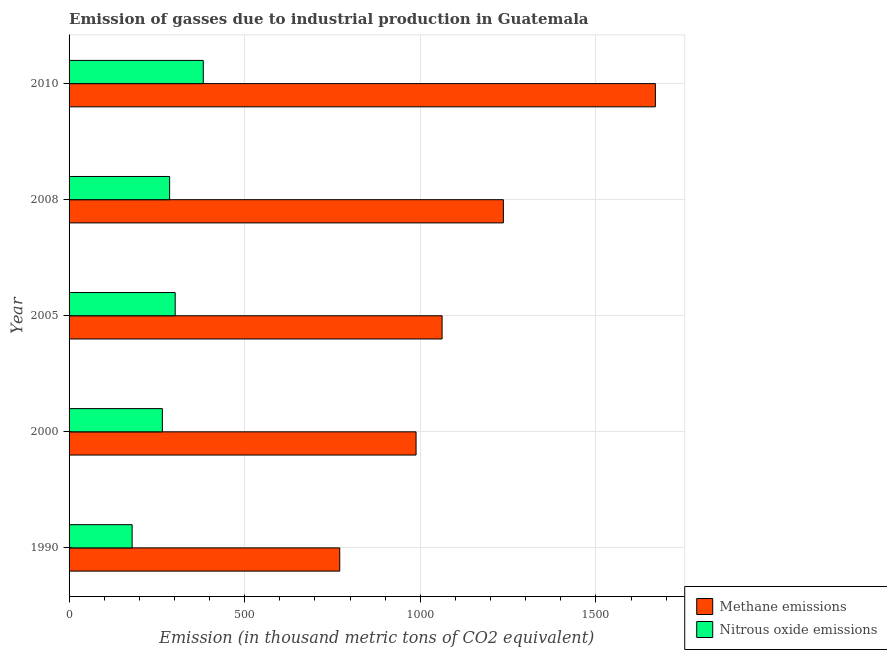How many different coloured bars are there?
Offer a terse response. 2. How many bars are there on the 5th tick from the bottom?
Make the answer very short. 2. In how many cases, is the number of bars for a given year not equal to the number of legend labels?
Your answer should be compact. 0. What is the amount of methane emissions in 2008?
Give a very brief answer. 1236.5. Across all years, what is the maximum amount of nitrous oxide emissions?
Provide a succinct answer. 382.1. Across all years, what is the minimum amount of nitrous oxide emissions?
Offer a very short reply. 179.5. In which year was the amount of nitrous oxide emissions maximum?
Provide a succinct answer. 2010. In which year was the amount of methane emissions minimum?
Your answer should be very brief. 1990. What is the total amount of methane emissions in the graph?
Provide a succinct answer. 5726.3. What is the difference between the amount of methane emissions in 1990 and that in 2005?
Your response must be concise. -291.4. What is the difference between the amount of methane emissions in 2010 and the amount of nitrous oxide emissions in 1990?
Offer a very short reply. 1489.8. What is the average amount of nitrous oxide emissions per year?
Make the answer very short. 283.12. In the year 2010, what is the difference between the amount of nitrous oxide emissions and amount of methane emissions?
Provide a short and direct response. -1287.2. In how many years, is the amount of nitrous oxide emissions greater than 900 thousand metric tons?
Provide a succinct answer. 0. What is the ratio of the amount of nitrous oxide emissions in 1990 to that in 2005?
Make the answer very short. 0.59. Is the difference between the amount of methane emissions in 2008 and 2010 greater than the difference between the amount of nitrous oxide emissions in 2008 and 2010?
Ensure brevity in your answer.  No. What is the difference between the highest and the second highest amount of nitrous oxide emissions?
Offer a very short reply. 80. What is the difference between the highest and the lowest amount of methane emissions?
Provide a short and direct response. 898.7. Is the sum of the amount of methane emissions in 2000 and 2008 greater than the maximum amount of nitrous oxide emissions across all years?
Offer a terse response. Yes. What does the 1st bar from the top in 1990 represents?
Offer a terse response. Nitrous oxide emissions. What does the 1st bar from the bottom in 2008 represents?
Your answer should be compact. Methane emissions. Are all the bars in the graph horizontal?
Offer a terse response. Yes. What is the difference between two consecutive major ticks on the X-axis?
Make the answer very short. 500. Does the graph contain grids?
Offer a terse response. Yes. Where does the legend appear in the graph?
Your answer should be compact. Bottom right. How many legend labels are there?
Keep it short and to the point. 2. What is the title of the graph?
Your response must be concise. Emission of gasses due to industrial production in Guatemala. Does "Technicians" appear as one of the legend labels in the graph?
Provide a succinct answer. No. What is the label or title of the X-axis?
Give a very brief answer. Emission (in thousand metric tons of CO2 equivalent). What is the label or title of the Y-axis?
Provide a succinct answer. Year. What is the Emission (in thousand metric tons of CO2 equivalent) in Methane emissions in 1990?
Keep it short and to the point. 770.6. What is the Emission (in thousand metric tons of CO2 equivalent) in Nitrous oxide emissions in 1990?
Your answer should be compact. 179.5. What is the Emission (in thousand metric tons of CO2 equivalent) in Methane emissions in 2000?
Your response must be concise. 987.9. What is the Emission (in thousand metric tons of CO2 equivalent) of Nitrous oxide emissions in 2000?
Your answer should be very brief. 265.6. What is the Emission (in thousand metric tons of CO2 equivalent) of Methane emissions in 2005?
Provide a succinct answer. 1062. What is the Emission (in thousand metric tons of CO2 equivalent) in Nitrous oxide emissions in 2005?
Make the answer very short. 302.1. What is the Emission (in thousand metric tons of CO2 equivalent) of Methane emissions in 2008?
Your answer should be compact. 1236.5. What is the Emission (in thousand metric tons of CO2 equivalent) of Nitrous oxide emissions in 2008?
Offer a very short reply. 286.3. What is the Emission (in thousand metric tons of CO2 equivalent) of Methane emissions in 2010?
Offer a very short reply. 1669.3. What is the Emission (in thousand metric tons of CO2 equivalent) of Nitrous oxide emissions in 2010?
Give a very brief answer. 382.1. Across all years, what is the maximum Emission (in thousand metric tons of CO2 equivalent) in Methane emissions?
Your response must be concise. 1669.3. Across all years, what is the maximum Emission (in thousand metric tons of CO2 equivalent) in Nitrous oxide emissions?
Your answer should be very brief. 382.1. Across all years, what is the minimum Emission (in thousand metric tons of CO2 equivalent) of Methane emissions?
Offer a terse response. 770.6. Across all years, what is the minimum Emission (in thousand metric tons of CO2 equivalent) in Nitrous oxide emissions?
Offer a very short reply. 179.5. What is the total Emission (in thousand metric tons of CO2 equivalent) of Methane emissions in the graph?
Give a very brief answer. 5726.3. What is the total Emission (in thousand metric tons of CO2 equivalent) in Nitrous oxide emissions in the graph?
Give a very brief answer. 1415.6. What is the difference between the Emission (in thousand metric tons of CO2 equivalent) of Methane emissions in 1990 and that in 2000?
Your answer should be compact. -217.3. What is the difference between the Emission (in thousand metric tons of CO2 equivalent) in Nitrous oxide emissions in 1990 and that in 2000?
Offer a very short reply. -86.1. What is the difference between the Emission (in thousand metric tons of CO2 equivalent) of Methane emissions in 1990 and that in 2005?
Your answer should be compact. -291.4. What is the difference between the Emission (in thousand metric tons of CO2 equivalent) in Nitrous oxide emissions in 1990 and that in 2005?
Provide a succinct answer. -122.6. What is the difference between the Emission (in thousand metric tons of CO2 equivalent) of Methane emissions in 1990 and that in 2008?
Provide a short and direct response. -465.9. What is the difference between the Emission (in thousand metric tons of CO2 equivalent) in Nitrous oxide emissions in 1990 and that in 2008?
Your answer should be very brief. -106.8. What is the difference between the Emission (in thousand metric tons of CO2 equivalent) of Methane emissions in 1990 and that in 2010?
Your answer should be compact. -898.7. What is the difference between the Emission (in thousand metric tons of CO2 equivalent) of Nitrous oxide emissions in 1990 and that in 2010?
Keep it short and to the point. -202.6. What is the difference between the Emission (in thousand metric tons of CO2 equivalent) in Methane emissions in 2000 and that in 2005?
Ensure brevity in your answer.  -74.1. What is the difference between the Emission (in thousand metric tons of CO2 equivalent) of Nitrous oxide emissions in 2000 and that in 2005?
Offer a very short reply. -36.5. What is the difference between the Emission (in thousand metric tons of CO2 equivalent) of Methane emissions in 2000 and that in 2008?
Offer a terse response. -248.6. What is the difference between the Emission (in thousand metric tons of CO2 equivalent) of Nitrous oxide emissions in 2000 and that in 2008?
Your response must be concise. -20.7. What is the difference between the Emission (in thousand metric tons of CO2 equivalent) in Methane emissions in 2000 and that in 2010?
Keep it short and to the point. -681.4. What is the difference between the Emission (in thousand metric tons of CO2 equivalent) in Nitrous oxide emissions in 2000 and that in 2010?
Offer a very short reply. -116.5. What is the difference between the Emission (in thousand metric tons of CO2 equivalent) of Methane emissions in 2005 and that in 2008?
Offer a very short reply. -174.5. What is the difference between the Emission (in thousand metric tons of CO2 equivalent) of Methane emissions in 2005 and that in 2010?
Offer a very short reply. -607.3. What is the difference between the Emission (in thousand metric tons of CO2 equivalent) in Nitrous oxide emissions in 2005 and that in 2010?
Make the answer very short. -80. What is the difference between the Emission (in thousand metric tons of CO2 equivalent) of Methane emissions in 2008 and that in 2010?
Offer a very short reply. -432.8. What is the difference between the Emission (in thousand metric tons of CO2 equivalent) of Nitrous oxide emissions in 2008 and that in 2010?
Offer a very short reply. -95.8. What is the difference between the Emission (in thousand metric tons of CO2 equivalent) of Methane emissions in 1990 and the Emission (in thousand metric tons of CO2 equivalent) of Nitrous oxide emissions in 2000?
Your answer should be compact. 505. What is the difference between the Emission (in thousand metric tons of CO2 equivalent) of Methane emissions in 1990 and the Emission (in thousand metric tons of CO2 equivalent) of Nitrous oxide emissions in 2005?
Your answer should be compact. 468.5. What is the difference between the Emission (in thousand metric tons of CO2 equivalent) of Methane emissions in 1990 and the Emission (in thousand metric tons of CO2 equivalent) of Nitrous oxide emissions in 2008?
Provide a succinct answer. 484.3. What is the difference between the Emission (in thousand metric tons of CO2 equivalent) in Methane emissions in 1990 and the Emission (in thousand metric tons of CO2 equivalent) in Nitrous oxide emissions in 2010?
Make the answer very short. 388.5. What is the difference between the Emission (in thousand metric tons of CO2 equivalent) in Methane emissions in 2000 and the Emission (in thousand metric tons of CO2 equivalent) in Nitrous oxide emissions in 2005?
Your answer should be very brief. 685.8. What is the difference between the Emission (in thousand metric tons of CO2 equivalent) in Methane emissions in 2000 and the Emission (in thousand metric tons of CO2 equivalent) in Nitrous oxide emissions in 2008?
Offer a very short reply. 701.6. What is the difference between the Emission (in thousand metric tons of CO2 equivalent) of Methane emissions in 2000 and the Emission (in thousand metric tons of CO2 equivalent) of Nitrous oxide emissions in 2010?
Keep it short and to the point. 605.8. What is the difference between the Emission (in thousand metric tons of CO2 equivalent) of Methane emissions in 2005 and the Emission (in thousand metric tons of CO2 equivalent) of Nitrous oxide emissions in 2008?
Provide a short and direct response. 775.7. What is the difference between the Emission (in thousand metric tons of CO2 equivalent) in Methane emissions in 2005 and the Emission (in thousand metric tons of CO2 equivalent) in Nitrous oxide emissions in 2010?
Ensure brevity in your answer.  679.9. What is the difference between the Emission (in thousand metric tons of CO2 equivalent) in Methane emissions in 2008 and the Emission (in thousand metric tons of CO2 equivalent) in Nitrous oxide emissions in 2010?
Your answer should be compact. 854.4. What is the average Emission (in thousand metric tons of CO2 equivalent) in Methane emissions per year?
Provide a succinct answer. 1145.26. What is the average Emission (in thousand metric tons of CO2 equivalent) of Nitrous oxide emissions per year?
Your answer should be compact. 283.12. In the year 1990, what is the difference between the Emission (in thousand metric tons of CO2 equivalent) in Methane emissions and Emission (in thousand metric tons of CO2 equivalent) in Nitrous oxide emissions?
Provide a succinct answer. 591.1. In the year 2000, what is the difference between the Emission (in thousand metric tons of CO2 equivalent) of Methane emissions and Emission (in thousand metric tons of CO2 equivalent) of Nitrous oxide emissions?
Offer a terse response. 722.3. In the year 2005, what is the difference between the Emission (in thousand metric tons of CO2 equivalent) in Methane emissions and Emission (in thousand metric tons of CO2 equivalent) in Nitrous oxide emissions?
Your answer should be very brief. 759.9. In the year 2008, what is the difference between the Emission (in thousand metric tons of CO2 equivalent) in Methane emissions and Emission (in thousand metric tons of CO2 equivalent) in Nitrous oxide emissions?
Give a very brief answer. 950.2. In the year 2010, what is the difference between the Emission (in thousand metric tons of CO2 equivalent) in Methane emissions and Emission (in thousand metric tons of CO2 equivalent) in Nitrous oxide emissions?
Offer a terse response. 1287.2. What is the ratio of the Emission (in thousand metric tons of CO2 equivalent) of Methane emissions in 1990 to that in 2000?
Your answer should be compact. 0.78. What is the ratio of the Emission (in thousand metric tons of CO2 equivalent) of Nitrous oxide emissions in 1990 to that in 2000?
Your answer should be very brief. 0.68. What is the ratio of the Emission (in thousand metric tons of CO2 equivalent) of Methane emissions in 1990 to that in 2005?
Provide a short and direct response. 0.73. What is the ratio of the Emission (in thousand metric tons of CO2 equivalent) of Nitrous oxide emissions in 1990 to that in 2005?
Your answer should be compact. 0.59. What is the ratio of the Emission (in thousand metric tons of CO2 equivalent) of Methane emissions in 1990 to that in 2008?
Provide a short and direct response. 0.62. What is the ratio of the Emission (in thousand metric tons of CO2 equivalent) in Nitrous oxide emissions in 1990 to that in 2008?
Provide a short and direct response. 0.63. What is the ratio of the Emission (in thousand metric tons of CO2 equivalent) in Methane emissions in 1990 to that in 2010?
Offer a terse response. 0.46. What is the ratio of the Emission (in thousand metric tons of CO2 equivalent) in Nitrous oxide emissions in 1990 to that in 2010?
Offer a very short reply. 0.47. What is the ratio of the Emission (in thousand metric tons of CO2 equivalent) in Methane emissions in 2000 to that in 2005?
Your answer should be very brief. 0.93. What is the ratio of the Emission (in thousand metric tons of CO2 equivalent) in Nitrous oxide emissions in 2000 to that in 2005?
Make the answer very short. 0.88. What is the ratio of the Emission (in thousand metric tons of CO2 equivalent) of Methane emissions in 2000 to that in 2008?
Make the answer very short. 0.8. What is the ratio of the Emission (in thousand metric tons of CO2 equivalent) in Nitrous oxide emissions in 2000 to that in 2008?
Offer a terse response. 0.93. What is the ratio of the Emission (in thousand metric tons of CO2 equivalent) in Methane emissions in 2000 to that in 2010?
Provide a succinct answer. 0.59. What is the ratio of the Emission (in thousand metric tons of CO2 equivalent) of Nitrous oxide emissions in 2000 to that in 2010?
Offer a terse response. 0.7. What is the ratio of the Emission (in thousand metric tons of CO2 equivalent) in Methane emissions in 2005 to that in 2008?
Provide a short and direct response. 0.86. What is the ratio of the Emission (in thousand metric tons of CO2 equivalent) of Nitrous oxide emissions in 2005 to that in 2008?
Your answer should be compact. 1.06. What is the ratio of the Emission (in thousand metric tons of CO2 equivalent) in Methane emissions in 2005 to that in 2010?
Give a very brief answer. 0.64. What is the ratio of the Emission (in thousand metric tons of CO2 equivalent) in Nitrous oxide emissions in 2005 to that in 2010?
Keep it short and to the point. 0.79. What is the ratio of the Emission (in thousand metric tons of CO2 equivalent) of Methane emissions in 2008 to that in 2010?
Ensure brevity in your answer.  0.74. What is the ratio of the Emission (in thousand metric tons of CO2 equivalent) of Nitrous oxide emissions in 2008 to that in 2010?
Ensure brevity in your answer.  0.75. What is the difference between the highest and the second highest Emission (in thousand metric tons of CO2 equivalent) of Methane emissions?
Offer a very short reply. 432.8. What is the difference between the highest and the lowest Emission (in thousand metric tons of CO2 equivalent) in Methane emissions?
Your answer should be compact. 898.7. What is the difference between the highest and the lowest Emission (in thousand metric tons of CO2 equivalent) of Nitrous oxide emissions?
Your answer should be very brief. 202.6. 